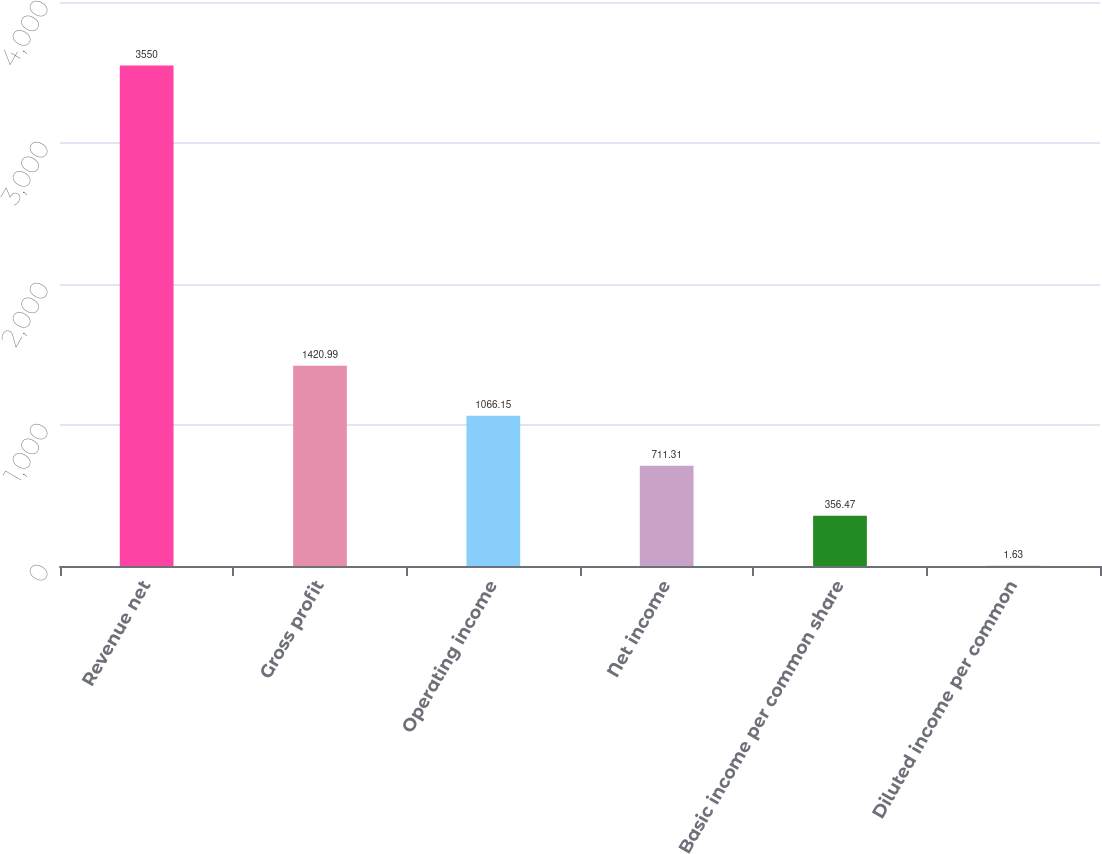<chart> <loc_0><loc_0><loc_500><loc_500><bar_chart><fcel>Revenue net<fcel>Gross profit<fcel>Operating income<fcel>Net income<fcel>Basic income per common share<fcel>Diluted income per common<nl><fcel>3550<fcel>1420.99<fcel>1066.15<fcel>711.31<fcel>356.47<fcel>1.63<nl></chart> 